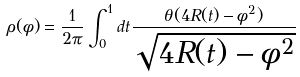<formula> <loc_0><loc_0><loc_500><loc_500>\rho ( \phi ) = \frac { 1 } { 2 \pi } \int _ { 0 } ^ { 1 } d t \frac { \theta ( 4 R ( t ) - \phi ^ { 2 } ) } { \sqrt { 4 R ( t ) - \phi ^ { 2 } } }</formula> 